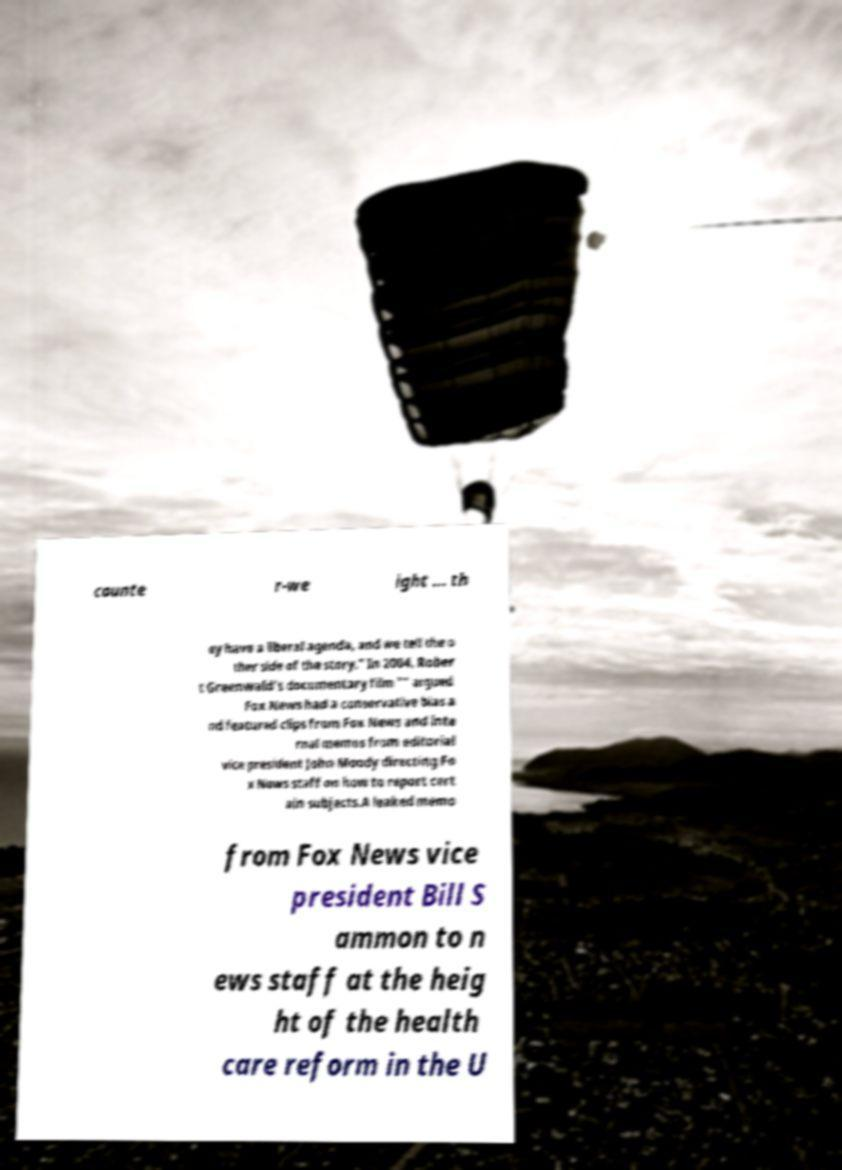Please identify and transcribe the text found in this image. counte r-we ight ... th ey have a liberal agenda, and we tell the o ther side of the story." In 2004, Rober t Greenwald's documentary film "" argued Fox News had a conservative bias a nd featured clips from Fox News and inte rnal memos from editorial vice president John Moody directing Fo x News staff on how to report cert ain subjects.A leaked memo from Fox News vice president Bill S ammon to n ews staff at the heig ht of the health care reform in the U 